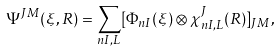Convert formula to latex. <formula><loc_0><loc_0><loc_500><loc_500>\Psi ^ { J M } ( \xi , { R } ) = \sum _ { n I , L } [ \Phi _ { n I } ( \xi ) \otimes \chi _ { n I , L } ^ { J } ( { R } ) ] _ { J M } ,</formula> 